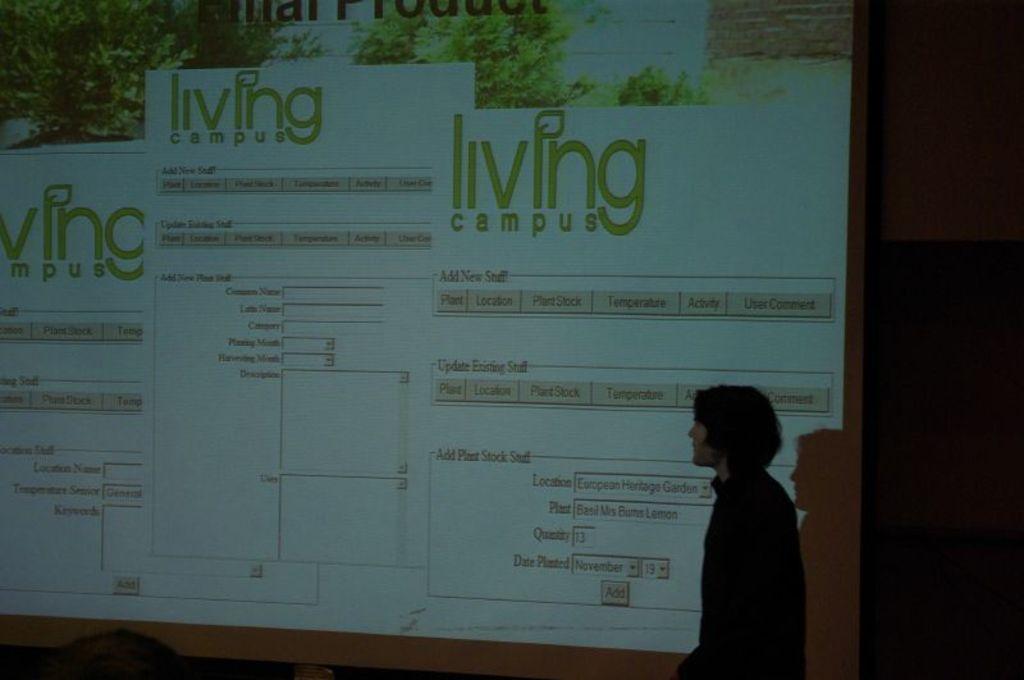What is the title of this ?
Provide a succinct answer. Living campus. What does it say under "living campus"?
Provide a short and direct response. Add new stuff. 